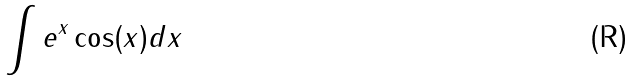Convert formula to latex. <formula><loc_0><loc_0><loc_500><loc_500>\int e ^ { x } \cos ( x ) d x</formula> 